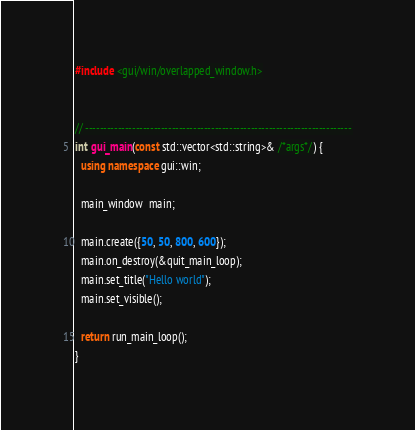Convert code to text. <code><loc_0><loc_0><loc_500><loc_500><_C++_>

#include <gui/win/overlapped_window.h>


// --------------------------------------------------------------------------
int gui_main(const std::vector<std::string>& /*args*/) {
  using namespace gui::win;

  main_window  main;

  main.create({50, 50, 800, 600});
  main.on_destroy(&quit_main_loop);
  main.set_title("Hello world");
  main.set_visible();

  return run_main_loop();
}
</code> 